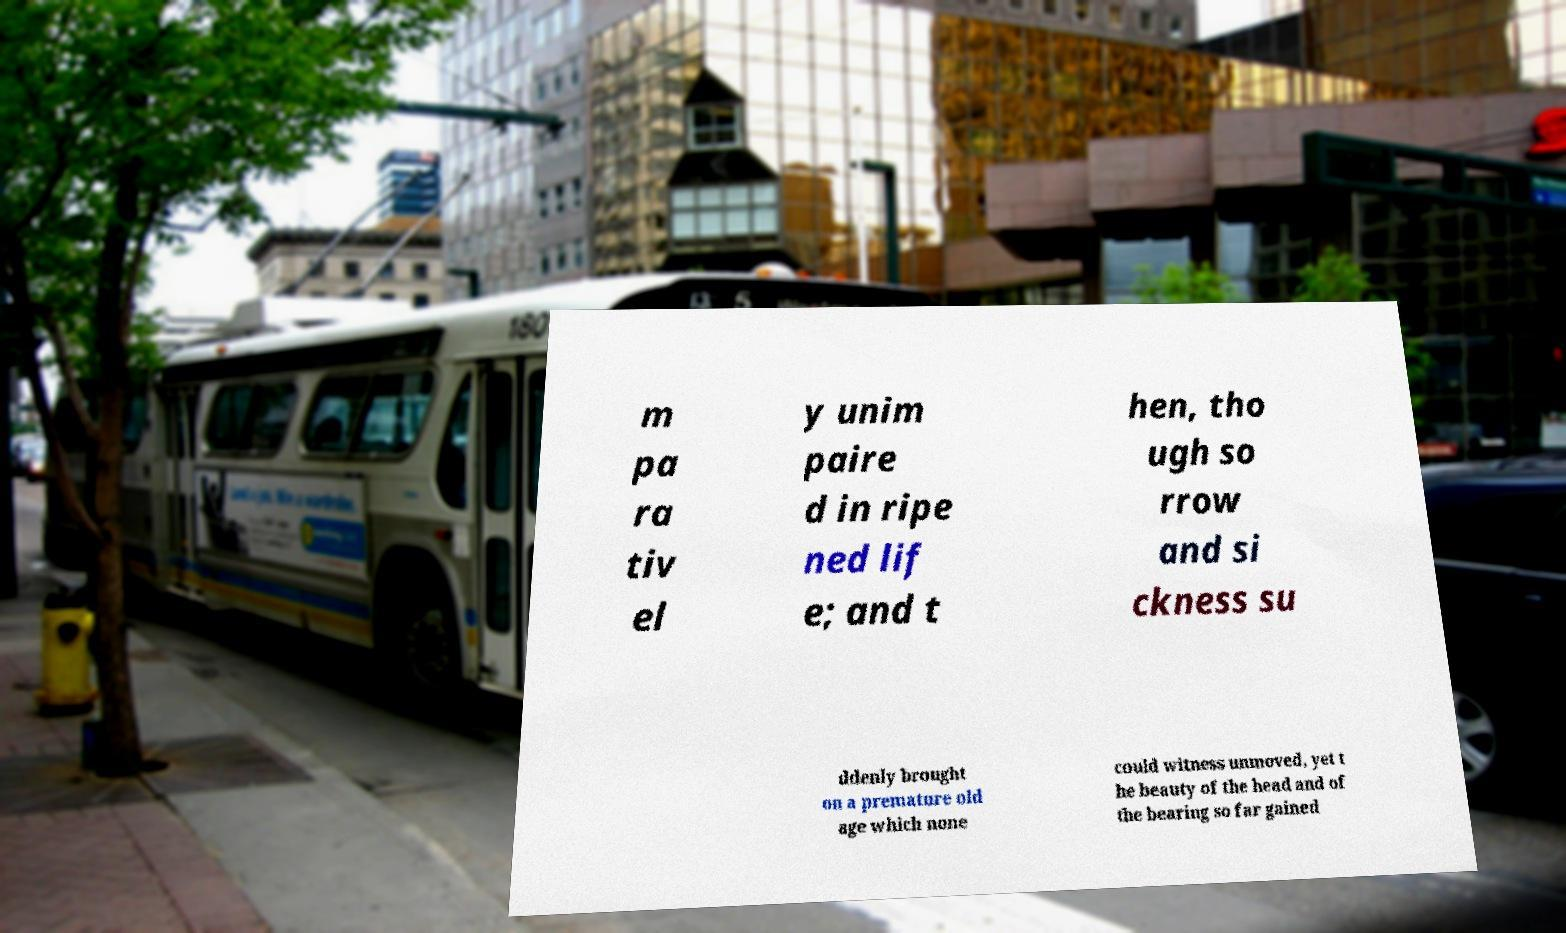I need the written content from this picture converted into text. Can you do that? m pa ra tiv el y unim paire d in ripe ned lif e; and t hen, tho ugh so rrow and si ckness su ddenly brought on a premature old age which none could witness unmoved, yet t he beauty of the head and of the bearing so far gained 